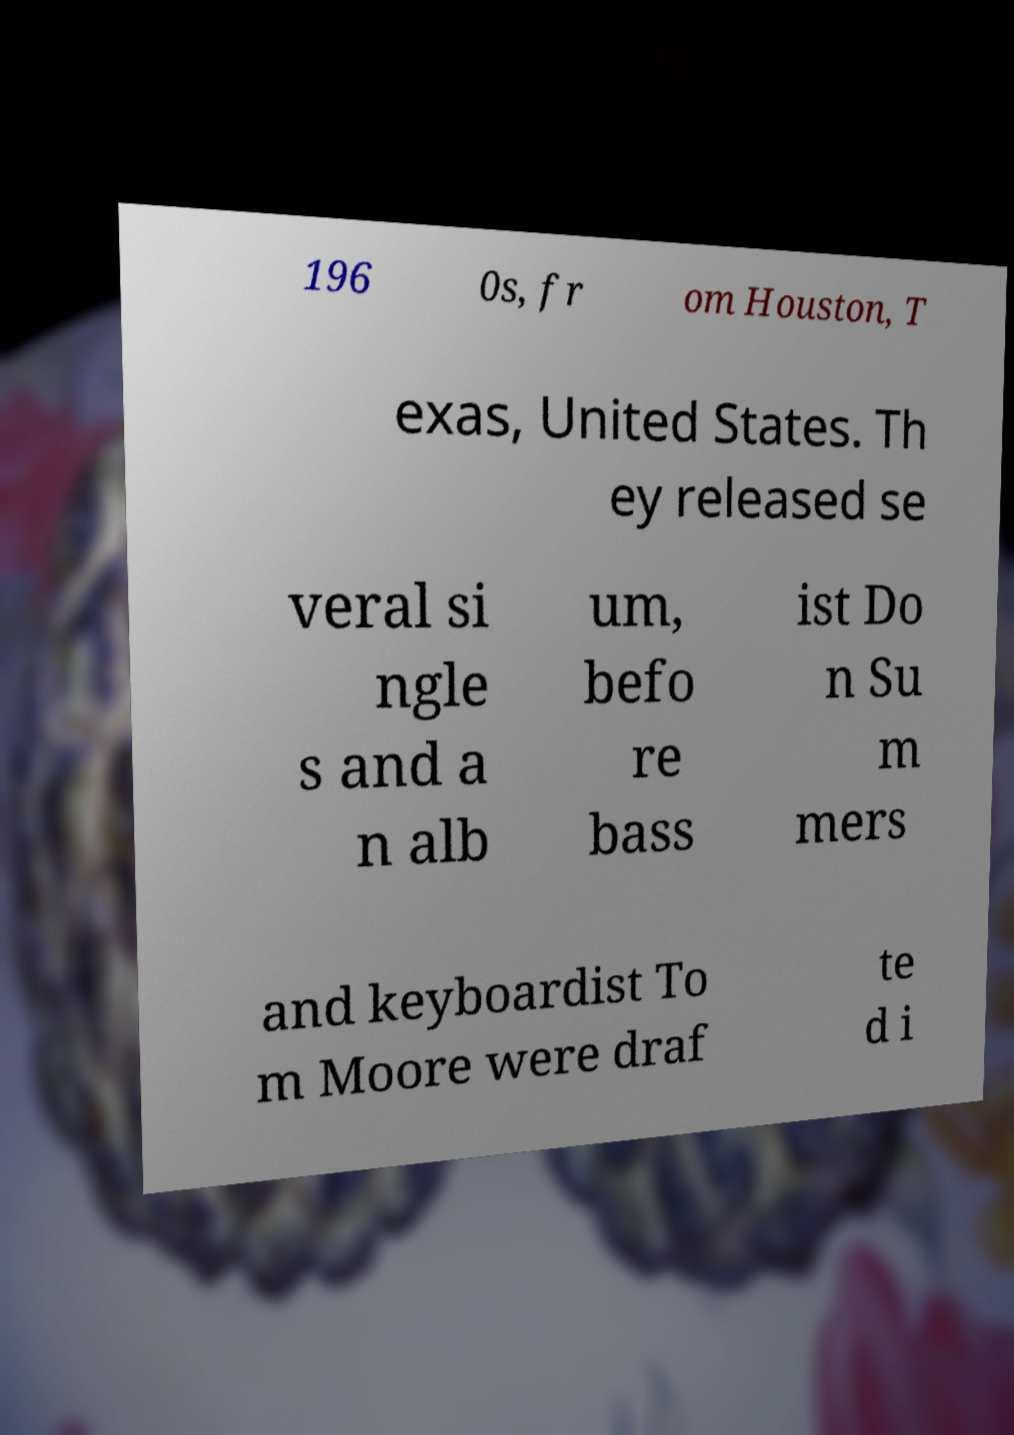Could you extract and type out the text from this image? 196 0s, fr om Houston, T exas, United States. Th ey released se veral si ngle s and a n alb um, befo re bass ist Do n Su m mers and keyboardist To m Moore were draf te d i 